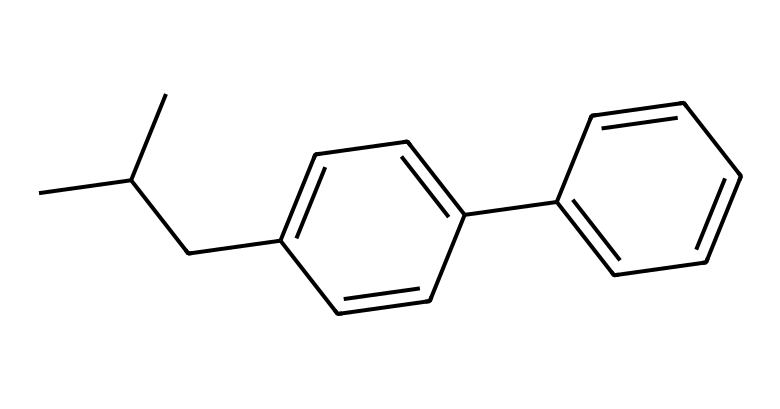What is the molecular formula of this chemical? To determine the molecular formula, identify the number of each type of atom in the structure. This chemical contains 15 carbon (C) atoms, 20 hydrogen (H) atoms, and no heteroatoms, leading to the formula C15H20.
Answer: C15H20 How many rings are present in this structure? Visually inspecting the structure, there are no closed loops or cyclic parts; the structure consists solely of linear and branched chains. Hence, the count of rings is zero.
Answer: 0 Is this chemical likely to be lipophilic or hydrophilic? The presence of multiple aromatic rings and the non-polar branching suggests that this molecule is more lipophilic. Lipophilicity increases with higher carbon content and the lack of polar-functional groups.
Answer: lipophilic What is the likely pharmacological category of this compound? Based on its structure, the molecule is indicative of a non-steroidal anti-inflammatory drug (NSAID), characterized by a branched alkyl chain and aromatic rings, commonly associated with anti-inflammatory properties.
Answer: NSAID How many stereocenters are in this molecule? By examining the structure, it can be concluded that there are two carbon atoms connected to four different substituents, which presents two stereocenters. Counting these centers yields a total of two stereocenters.
Answer: 2 What type of substitutions characterize the functional groups in this drug? The structure is characterized by alkyl and aryl groups with no polar functional groups, primarily indicating hydrophobic characteristics which are common in NSAIDs. This lack of polar functional groups also suggests a low degree of water solubility.
Answer: hydrophobic 